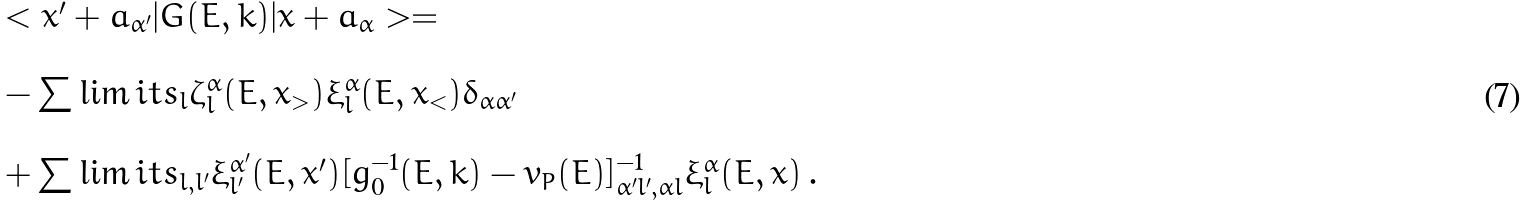Convert formula to latex. <formula><loc_0><loc_0><loc_500><loc_500>\begin{array} { l } < x ^ { \prime } + a _ { \alpha ^ { \prime } } | G ( E , k ) | x + a _ { \alpha } > = \\ \\ - \sum \lim i t s _ { l } \zeta _ { l } ^ { \alpha } ( E , x _ { > } ) \xi _ { l } ^ { \alpha } ( E , x _ { < } ) \delta _ { \alpha \alpha ^ { \prime } } \\ \\ + \sum \lim i t s _ { l , l ^ { \prime } } \xi _ { l ^ { \prime } } ^ { \alpha ^ { \prime } } ( E , x ^ { \prime } ) [ g _ { 0 } ^ { - 1 } ( E , k ) - v _ { P } ( E ) ] ^ { - 1 } _ { \alpha ^ { \prime } l ^ { \prime } , \alpha l } \xi _ { l } ^ { \alpha } ( E , x ) \, . \end{array}</formula> 